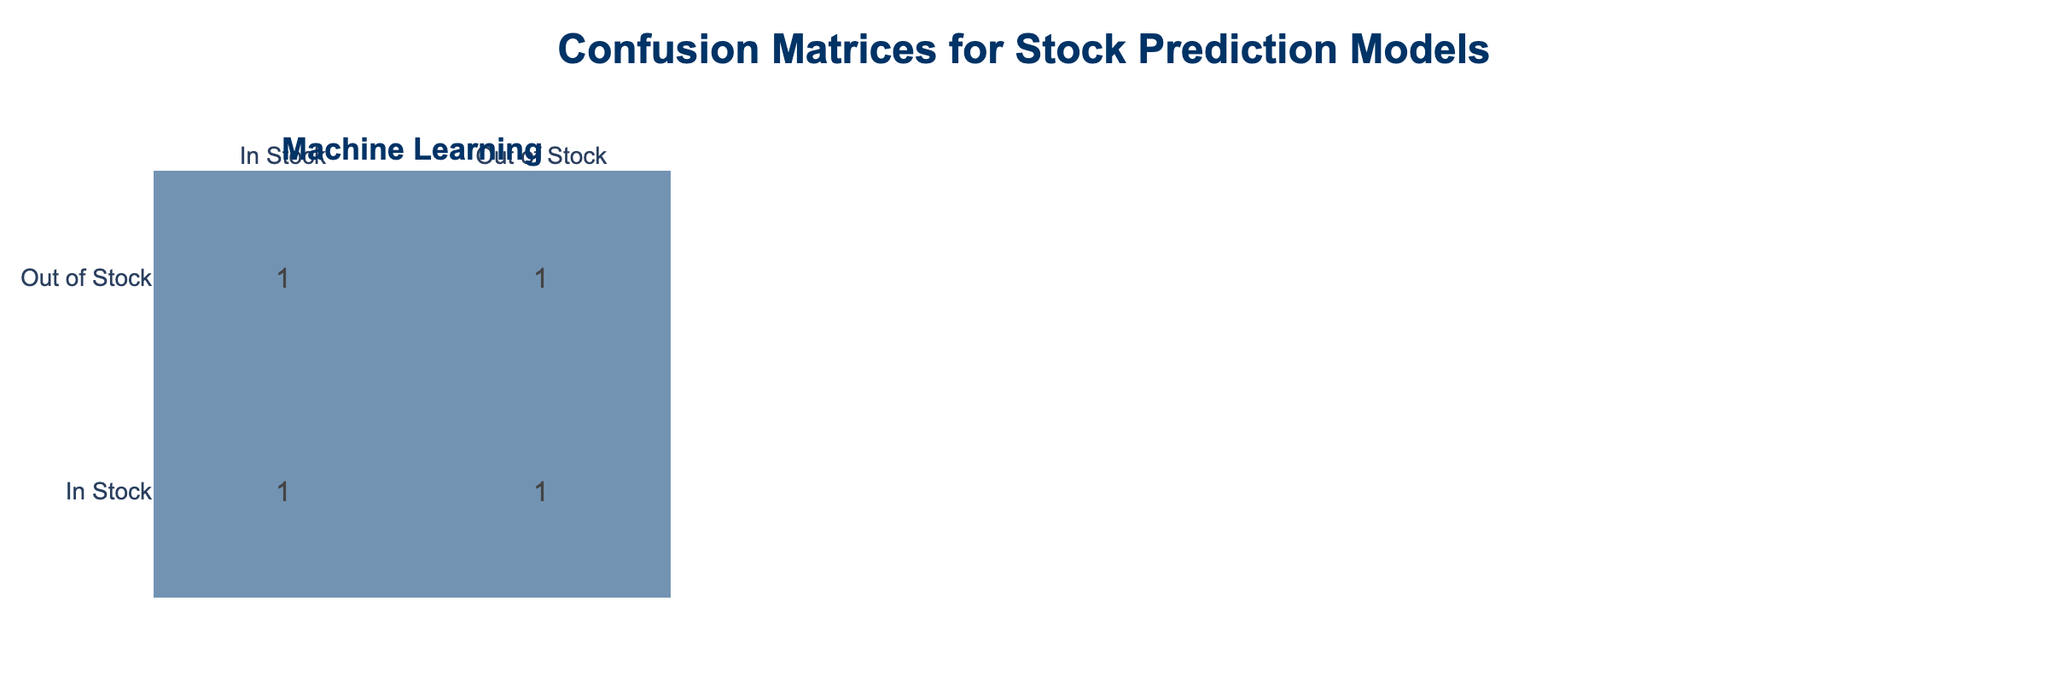What is the count of predictions for "In Stock" using the Simple Moving Average model? There are 3 instances where the predicted stock is "In Stock" for the Simple Moving Average model; these are: (1) Actual In Stock, Predicted In Stock, (2) Actual Out of Stock, Predicted In Stock, and (3) Actual In Stock, Predicted In Stock that sum up to 3.
Answer: 3 How many times did the Exponential Smoothing model fail to predict "In Stock" accurately? There are 2 instances where the actual stock was "In Stock" but the predicted stock was "Out of Stock" for the Exponential Smoothing model, indicating failure in prediction (i.e., In Stock, Out of Stock).
Answer: 2 What is the total number of predictions made by the Machine Learning model? The Machine Learning model makes a total of 4 predictions: 2 for "In Stock" and 2 for "Out of Stock," as seen in the respective counts for each prediction type.
Answer: 4 Did any model successfully predict all of its stocks as "Out of Stock"? Yes, the Machine Learning model successfully predicted the actual stock as "Out of Stock" in one instance.
Answer: Yes Which model has the highest count of false positives (predicted "In Stock" when actually "Out of Stock")? The Simple Moving Average model has a count of 1 false positive based on the lone instance where the actual stock was "Out of Stock" but predicted as "In Stock." The same applies to Exponential Smoothing and Machine Learning.
Answer: Simple Moving Average, Exponential Smoothing, and Machine Learning all have equal false positives (1) What is the ratio of correct predictions to incorrect predictions for the Machine Learning model? The Machine Learning model has 2 correct predictions (Out of Stock, Out of Stock) and 2 incorrect predictions (Out of Stock, In Stock). To find the ratio, we calculate 2 (correct) to 2 (incorrect), which simplifies to 1:1.
Answer: 1:1 What percentage of all predictions made by the Simple Moving Average model were correct? In the Simple Moving Average model, there are 3 correct predictions (In Stock, In Stock & Out of Stock, Out of Stock) and 1 incorrect prediction (Out of Stock, In Stock). Thus, the correct percentage is calculated as (3 correct / 4 total) * 100 = 75%.
Answer: 75% How many total instances are there for all models combined? There are a total of 12 instances listed for the various stock predictions across all models, which can be calculated by counting all rows in the data table.
Answer: 12 What is the most common type of prediction for the Exponential Smoothing model? The most common prediction type for the Exponential Smoothing model is "Out of Stock," which occurs 2 times out of its 4 predictions based on the crosstable for the model.
Answer: Out of Stock 